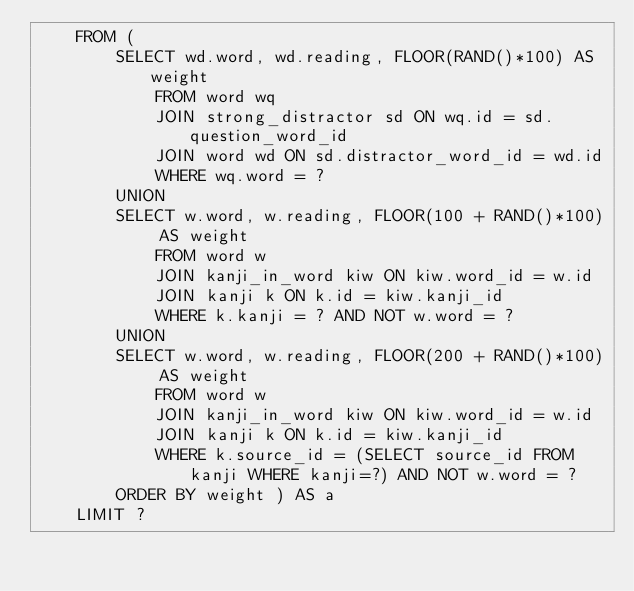<code> <loc_0><loc_0><loc_500><loc_500><_SQL_>    FROM (
        SELECT wd.word, wd.reading, FLOOR(RAND()*100) AS weight
            FROM word wq
            JOIN strong_distractor sd ON wq.id = sd.question_word_id
            JOIN word wd ON sd.distractor_word_id = wd.id
            WHERE wq.word = ?
        UNION
        SELECT w.word, w.reading, FLOOR(100 + RAND()*100) AS weight
            FROM word w
            JOIN kanji_in_word kiw ON kiw.word_id = w.id
            JOIN kanji k ON k.id = kiw.kanji_id
            WHERE k.kanji = ? AND NOT w.word = ?
        UNION
        SELECT w.word, w.reading, FLOOR(200 + RAND()*100) AS weight
            FROM word w
            JOIN kanji_in_word kiw ON kiw.word_id = w.id
            JOIN kanji k ON k.id = kiw.kanji_id
            WHERE k.source_id = (SELECT source_id FROM kanji WHERE kanji=?) AND NOT w.word = ?
        ORDER BY weight ) AS a
    LIMIT ?</code> 